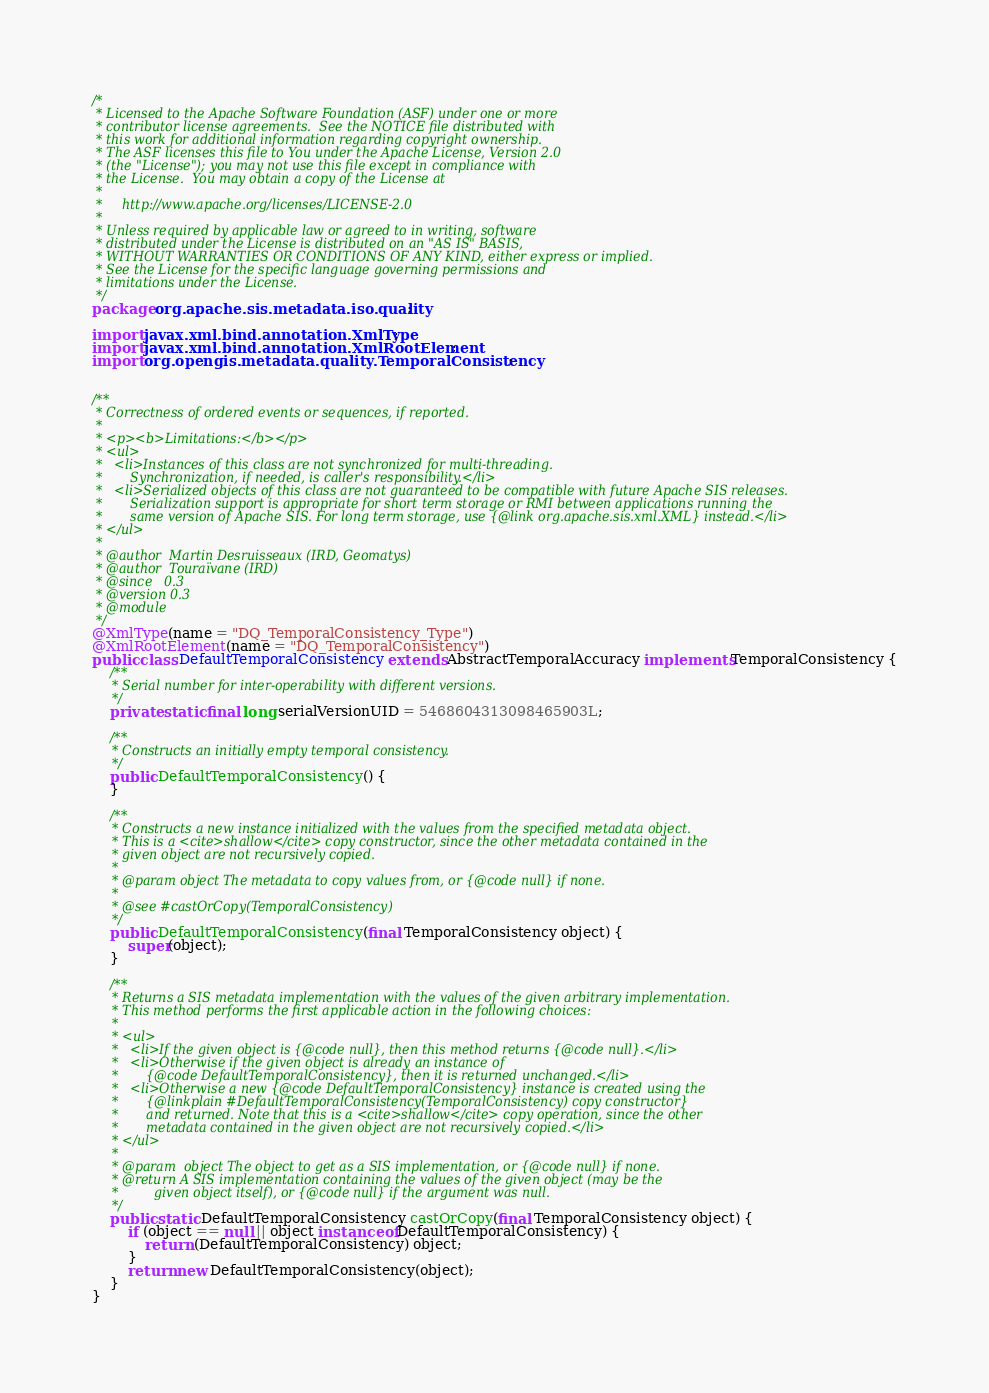<code> <loc_0><loc_0><loc_500><loc_500><_Java_>/*
 * Licensed to the Apache Software Foundation (ASF) under one or more
 * contributor license agreements.  See the NOTICE file distributed with
 * this work for additional information regarding copyright ownership.
 * The ASF licenses this file to You under the Apache License, Version 2.0
 * (the "License"); you may not use this file except in compliance with
 * the License.  You may obtain a copy of the License at
 *
 *     http://www.apache.org/licenses/LICENSE-2.0
 *
 * Unless required by applicable law or agreed to in writing, software
 * distributed under the License is distributed on an "AS IS" BASIS,
 * WITHOUT WARRANTIES OR CONDITIONS OF ANY KIND, either express or implied.
 * See the License for the specific language governing permissions and
 * limitations under the License.
 */
package org.apache.sis.metadata.iso.quality;

import javax.xml.bind.annotation.XmlType;
import javax.xml.bind.annotation.XmlRootElement;
import org.opengis.metadata.quality.TemporalConsistency;


/**
 * Correctness of ordered events or sequences, if reported.
 *
 * <p><b>Limitations:</b></p>
 * <ul>
 *   <li>Instances of this class are not synchronized for multi-threading.
 *       Synchronization, if needed, is caller's responsibility.</li>
 *   <li>Serialized objects of this class are not guaranteed to be compatible with future Apache SIS releases.
 *       Serialization support is appropriate for short term storage or RMI between applications running the
 *       same version of Apache SIS. For long term storage, use {@link org.apache.sis.xml.XML} instead.</li>
 * </ul>
 *
 * @author  Martin Desruisseaux (IRD, Geomatys)
 * @author  Touraïvane (IRD)
 * @since   0.3
 * @version 0.3
 * @module
 */
@XmlType(name = "DQ_TemporalConsistency_Type")
@XmlRootElement(name = "DQ_TemporalConsistency")
public class DefaultTemporalConsistency extends AbstractTemporalAccuracy implements TemporalConsistency {
    /**
     * Serial number for inter-operability with different versions.
     */
    private static final long serialVersionUID = 5468604313098465903L;

    /**
     * Constructs an initially empty temporal consistency.
     */
    public DefaultTemporalConsistency() {
    }

    /**
     * Constructs a new instance initialized with the values from the specified metadata object.
     * This is a <cite>shallow</cite> copy constructor, since the other metadata contained in the
     * given object are not recursively copied.
     *
     * @param object The metadata to copy values from, or {@code null} if none.
     *
     * @see #castOrCopy(TemporalConsistency)
     */
    public DefaultTemporalConsistency(final TemporalConsistency object) {
        super(object);
    }

    /**
     * Returns a SIS metadata implementation with the values of the given arbitrary implementation.
     * This method performs the first applicable action in the following choices:
     *
     * <ul>
     *   <li>If the given object is {@code null}, then this method returns {@code null}.</li>
     *   <li>Otherwise if the given object is already an instance of
     *       {@code DefaultTemporalConsistency}, then it is returned unchanged.</li>
     *   <li>Otherwise a new {@code DefaultTemporalConsistency} instance is created using the
     *       {@linkplain #DefaultTemporalConsistency(TemporalConsistency) copy constructor}
     *       and returned. Note that this is a <cite>shallow</cite> copy operation, since the other
     *       metadata contained in the given object are not recursively copied.</li>
     * </ul>
     *
     * @param  object The object to get as a SIS implementation, or {@code null} if none.
     * @return A SIS implementation containing the values of the given object (may be the
     *         given object itself), or {@code null} if the argument was null.
     */
    public static DefaultTemporalConsistency castOrCopy(final TemporalConsistency object) {
        if (object == null || object instanceof DefaultTemporalConsistency) {
            return (DefaultTemporalConsistency) object;
        }
        return new DefaultTemporalConsistency(object);
    }
}
</code> 